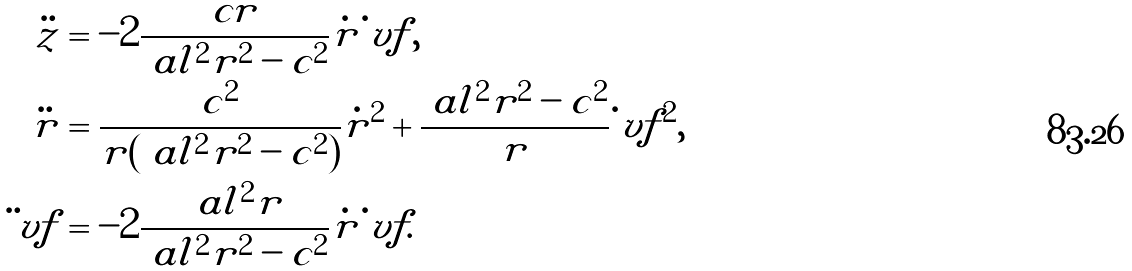<formula> <loc_0><loc_0><loc_500><loc_500>\ddot { z } & = - 2 \frac { c r } { \ a l ^ { 2 } r ^ { 2 } - c ^ { 2 } } \dot { r } \dot { \ } v f , \\ \ddot { r } & = \frac { c ^ { 2 } } { r ( \ a l ^ { 2 } r ^ { 2 } - c ^ { 2 } ) } \dot { r } ^ { 2 } + \frac { \ a l ^ { 2 } r ^ { 2 } - c ^ { 2 } } r \dot { \ } v f ^ { 2 } , \\ \ddot { \ } v f & = - 2 \frac { \ a l ^ { 2 } r } { \ a l ^ { 2 } r ^ { 2 } - c ^ { 2 } } \dot { r } \dot { \ } v f .</formula> 